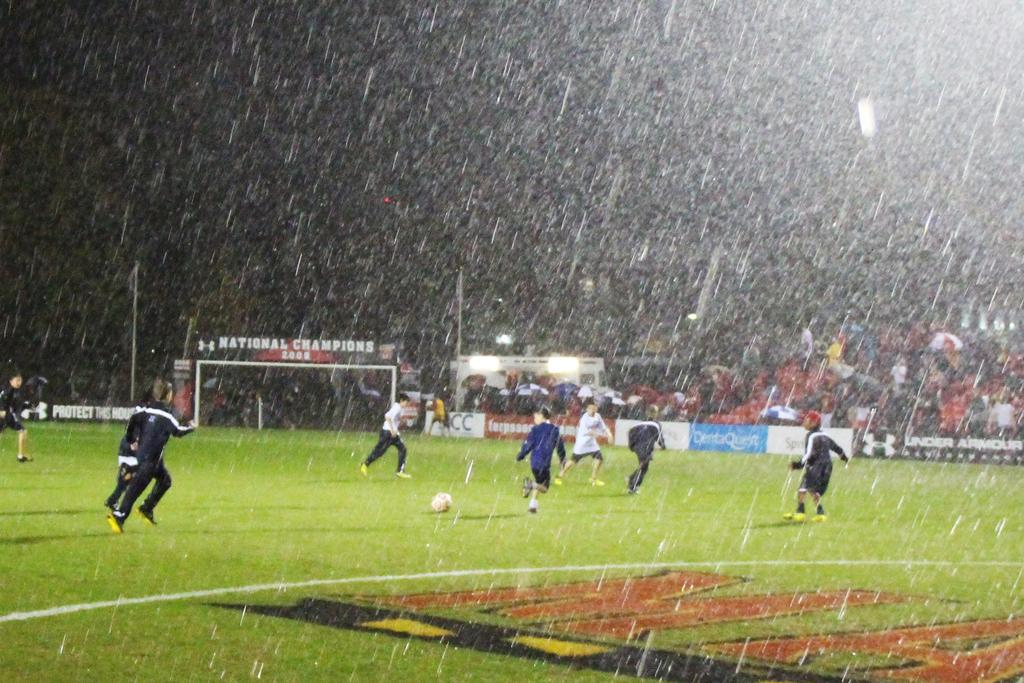<image>
Give a short and clear explanation of the subsequent image. Two teams play soccer in heavy rain ona field with banners for Under Armour and CentaQuest in the background. 